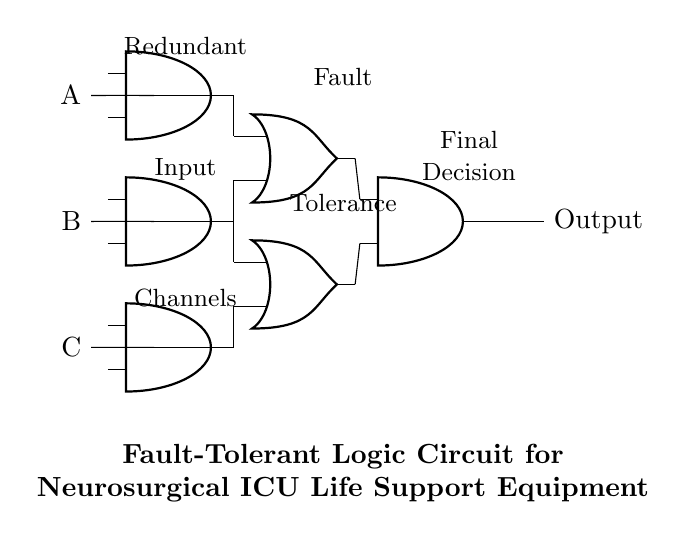What components are present in the circuit? The circuit contains AND gates, OR gates, and input channels. These components are typically used to perform logical operations. The AND gates process the input signals, and the OR gates combine their outputs.
Answer: AND gates, OR gates, input channels How many input channels are there in the circuit? The circuit diagram shows three input channels labeled A, B, and C at the start of the circuit. Each channel represents a different input signal necessary for the logic circuit's operation.
Answer: Three What is the purpose of the redundant input channels? Redundant input channels are implemented to enhance fault tolerance in the circuit. They allow the system to continue functioning correctly even if one or more inputs fail, which is crucial for patient safety in life support equipment.
Answer: Fault tolerance Which gates are in the second layer of the circuit? The second layer of the circuit includes two OR gates, which receive outputs from the first layer of AND gates. The OR gates are essential for combining multiple input conditions to produce a final output.
Answer: OR gates How many AND gates are there in the circuit? The circuit diagram illustrates four AND gates: three in the first layer and one in the final layer responsible for processing the outputs of the OR gates. This configuration enables complex logical decision-making.
Answer: Four What does the output represent in this circuit? The output represents the final decision based on the logical operations performed by the combination of AND and OR gates, ultimately determining the state of the life support equipment based on the incoming signals.
Answer: Final decision 